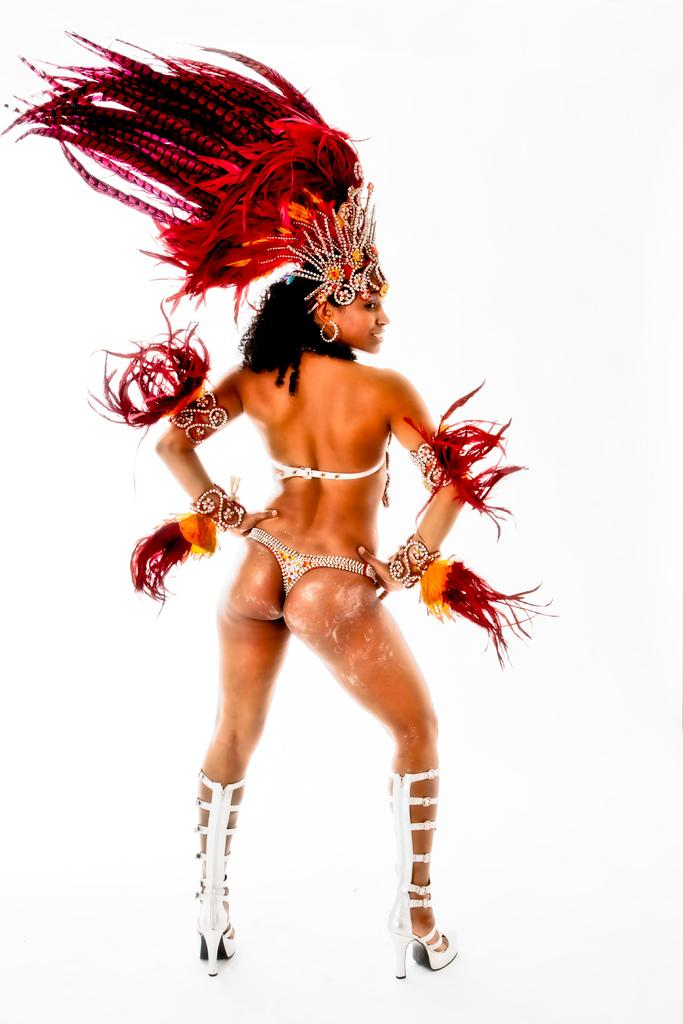Who is present in the image? There is a woman in the image. What is the woman doing in the image? The woman is standing and smiling. What type of shoes is the woman wearing? The woman is wearing heels. What type of clothing is the woman wearing? The woman is wearing a fancy dress and a crown. What can be seen in the image besides the woman? There are red feathers in the image. What is the color of the background in the image? The background of the image appears white. What type of friction can be seen between the woman's feet and the ground in the image? There is no visible friction between the woman's feet and the ground in the image. What is the woman writing in the image? The woman is not writing anything in the image. 